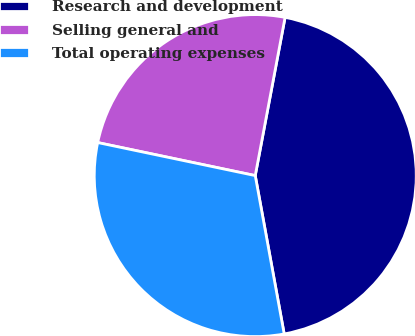<chart> <loc_0><loc_0><loc_500><loc_500><pie_chart><fcel>Research and development<fcel>Selling general and<fcel>Total operating expenses<nl><fcel>44.16%<fcel>24.68%<fcel>31.17%<nl></chart> 